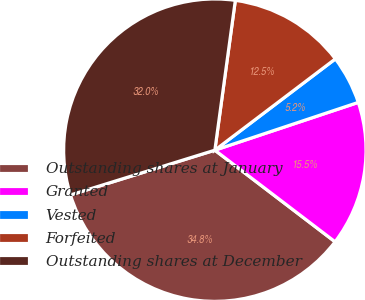<chart> <loc_0><loc_0><loc_500><loc_500><pie_chart><fcel>Outstanding shares at January<fcel>Granted<fcel>Vested<fcel>Forfeited<fcel>Outstanding shares at December<nl><fcel>34.85%<fcel>15.48%<fcel>5.2%<fcel>12.52%<fcel>31.95%<nl></chart> 